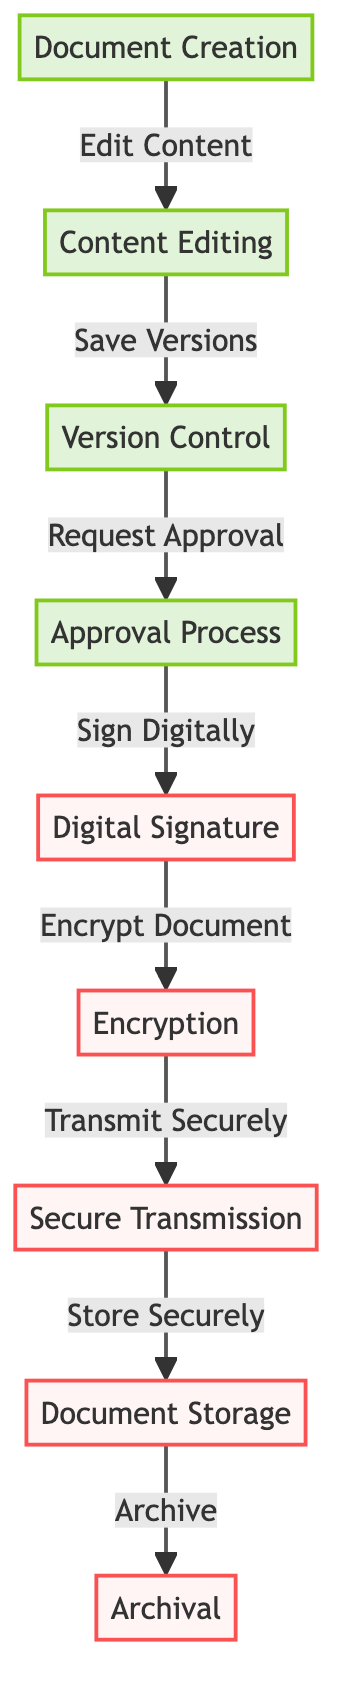What is the first step in the document workflow? The first step in the document workflow is "Document Creation," as indicated at the very beginning of the flowchart.
Answer: Document Creation How many processes are in the workflow? The workflow consists of six processes: Document Creation, Content Editing, Version Control, Approval Process, Digital Signature, and Archival.
Answer: Six What node comes after the approval process? After the approval process, the next node is "Digital Signature," which is directly linked to the approval process in the flowchart.
Answer: Digital Signature What type of node is "Encryption"? "Encryption" is categorized under security, as indicated by the color coding in the diagram.
Answer: Security Which process is responsible for saving document versions? The process responsible for saving document versions is "Version Control." This is indicated by the direct link from Content Editing to Version Control in the workflow.
Answer: Version Control What does the digital signature process lead to? The digital signature process leads to "Encryption," as indicated by the arrow connecting these two nodes in the diagram.
Answer: Encryption Which processes are related to document storage? The processes related to document storage are "Secure Transmission," "Document Storage," and "Archival," as they are all sequentially linked in that part of the workflow.
Answer: Secure Transmission, Document Storage, Archival How many security-related steps are present in the workflow? There are four security-related steps: Digital Signature, Encryption, Secure Transmission, and Document Storage, all classified as security in the diagram.
Answer: Four What is the last step in the document workflow? The last step in the document workflow is "Archival," which follows directly after Document Storage.
Answer: Archival 